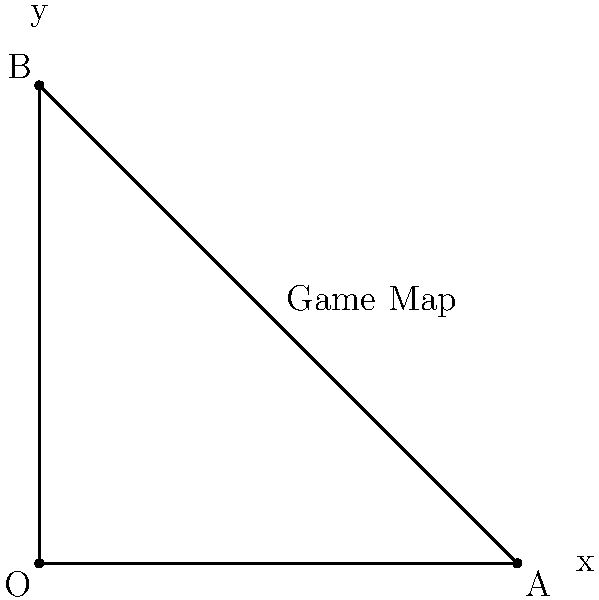In creating a custom coordinate system for a globalized game map using C#, you need to transform the standard Cartesian coordinates to a new system where point A(2,0) becomes (1,0) and point B(0,2) becomes (0,1) in the new system. What C# method would you implement to convert a point from the original system to the new system, and what would be the formula for this transformation? To create a custom coordinate system for the game map, we need to implement a method that transforms the original coordinates to the new system. Here's a step-by-step approach:

1. Analyze the transformation:
   - Point A(2,0) in the original system becomes (1,0) in the new system
   - Point B(0,2) in the original system becomes (0,1) in the new system

2. Determine the scaling factors:
   - X-axis: 2 units in the original system = 1 unit in the new system
   - Y-axis: 2 units in the original system = 1 unit in the new system

3. Calculate the scaling factors:
   - X scaling factor: $\frac{1}{2}$
   - Y scaling factor: $\frac{1}{2}$

4. Create a C# method to perform the transformation:
   ```csharp
   public static Point TransformCoordinate(Point originalPoint)
   {
       float newX = originalPoint.X * 0.5f;
       float newY = originalPoint.Y * 0.5f;
       return new Point(newX, newY);
   }
   ```

5. The formula for this transformation can be expressed as:
   $$\begin{cases}
   x_{new} = \frac{1}{2}x_{original} \\
   y_{new} = \frac{1}{2}y_{original}
   \end{cases}$$

This method and formula will correctly transform points from the original coordinate system to the new custom system for the globalized game map.
Answer: TransformCoordinate method with formula: $x_{new} = \frac{1}{2}x_{original}$, $y_{new} = \frac{1}{2}y_{original}$ 